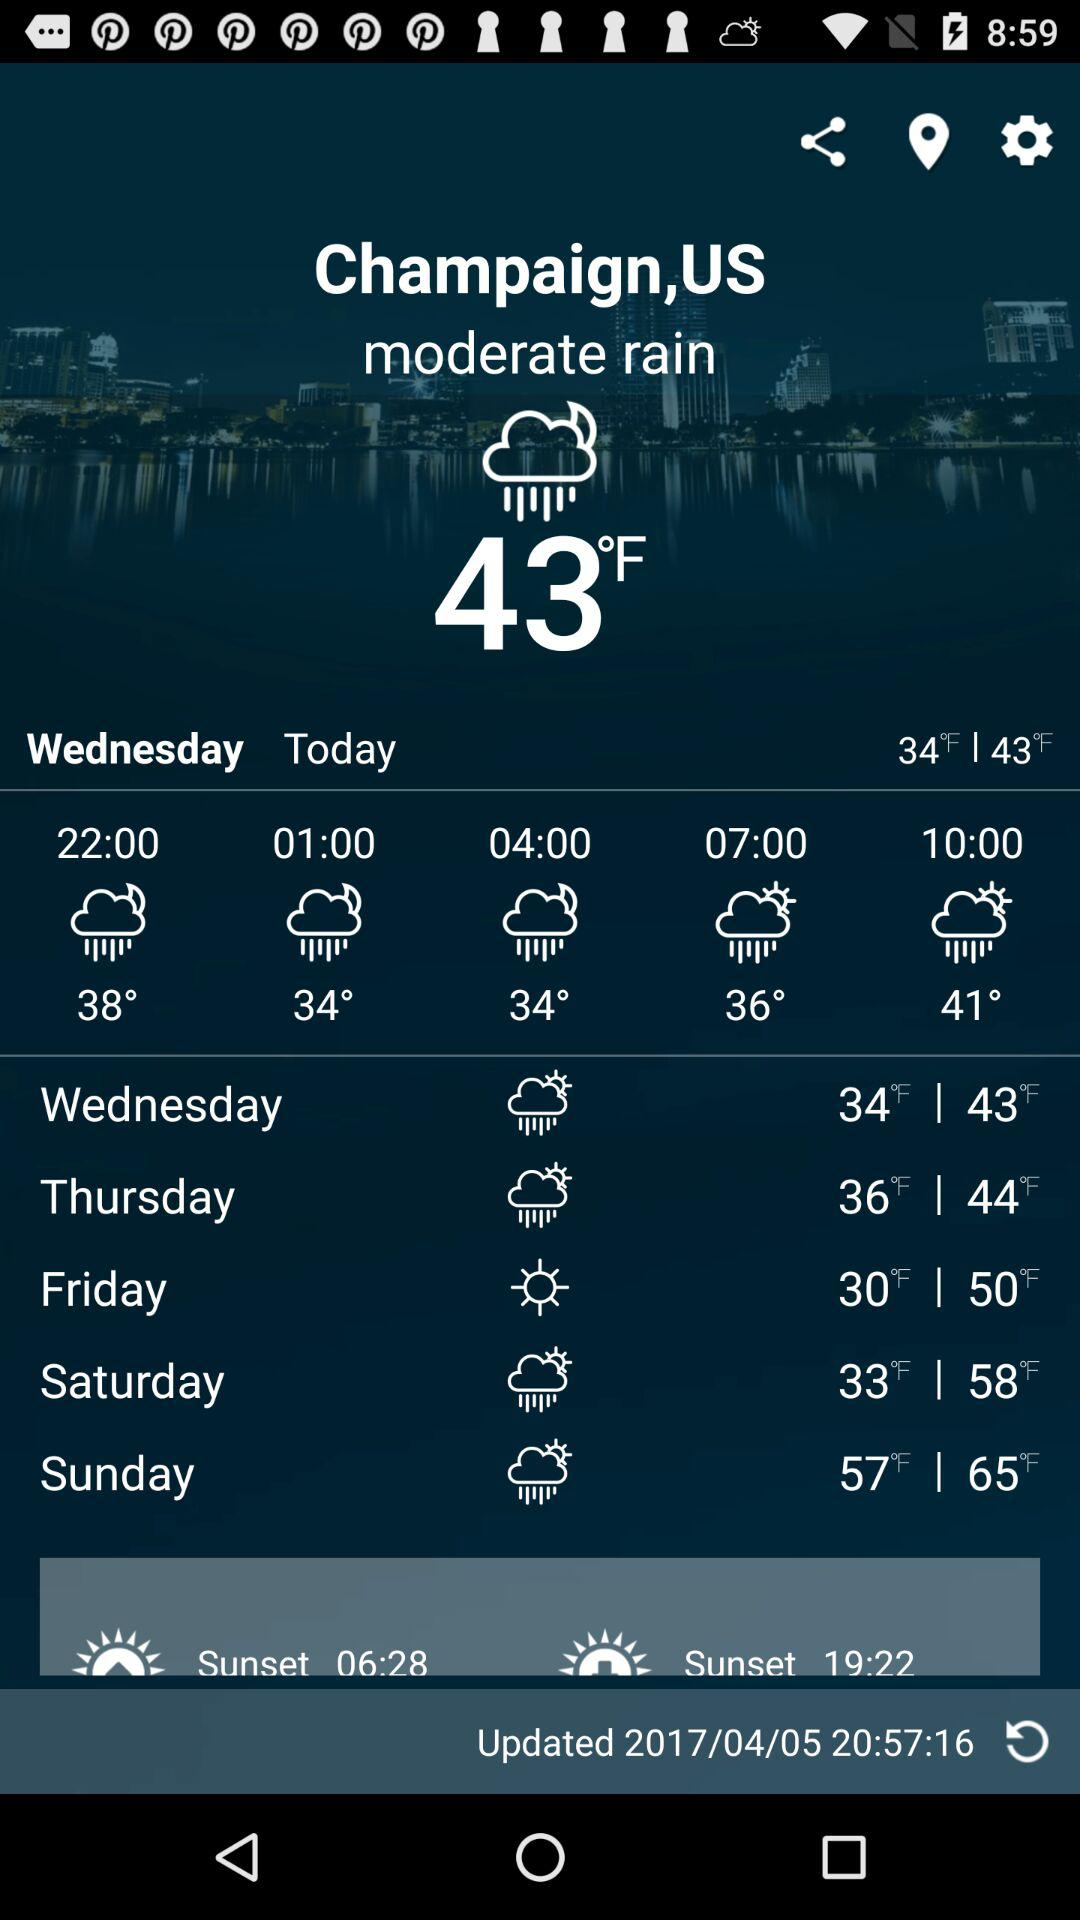Which day is it today?
Answer the question using a single word or phrase. Today is Wednesday. 